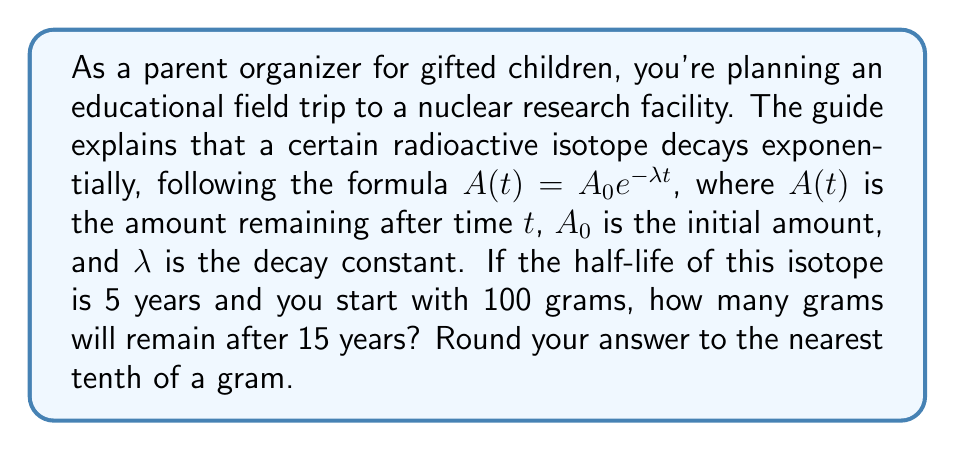Give your solution to this math problem. Let's approach this step-by-step:

1) First, we need to find the decay constant $\lambda$ using the half-life.
   The half-life formula is: $t_{1/2} = \frac{\ln(2)}{\lambda}$
   
   Rearranging this, we get: $\lambda = \frac{\ln(2)}{t_{1/2}}$

2) We know $t_{1/2} = 5$ years, so:
   $\lambda = \frac{\ln(2)}{5} \approx 0.1386$

3) Now we can use the decay formula:
   $A(t) = A_0 e^{-\lambda t}$

   Where:
   $A_0 = 100$ grams (initial amount)
   $\lambda \approx 0.1386$ (decay constant we just calculated)
   $t = 15$ years (time elapsed)

4) Plugging these values into the formula:
   $A(15) = 100 e^{-0.1386 \times 15}$

5) Calculating this:
   $A(15) = 100 e^{-2.079} \approx 12.5$ grams

6) Rounding to the nearest tenth of a gram:
   $A(15) \approx 12.5$ grams

This problem demonstrates exponential decay in radioactive materials, which is relevant in fields such as nuclear physics, radiometric dating, and medical imaging.
Answer: 12.5 grams 